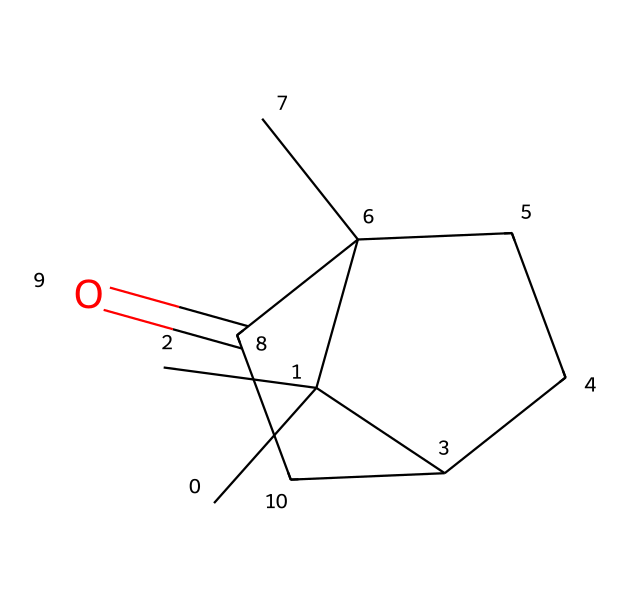What is the main functional group in camphor? The chemical structure of camphor contains a ketone group, identifiable by the carbonyl (C=O) bonded to two other carbon atoms. This functional group indicates that camphor is a ketone.
Answer: ketone How many carbon atoms are in the molecular structure of camphor? By analyzing the structure, we can count the number of carbon atoms in the skeleton. The chemical representation shows a total of 10 carbon atoms linked together.
Answer: 10 What type of molecule is camphor categorized as? Based on its structure and functional groups, camphor is identified as a bicyclic monoterpene, since it consists of two fused rings and has a total of 10 carbon atoms typical for monoterpenes.
Answer: bicyclic monoterpene What is the molecular formula of camphor? By calculating based on the number of carbon, hydrogen, and oxygen atoms in the structure, the molecular formula is deduced to be C10H16O.
Answer: C10H16O Does camphor have aromatic characteristics? The structure does not feature any delocalized pi electrons or planar ring systems characteristics of aromatic compounds, as it consists of closed, saturated rings without resonance.
Answer: no What is the use of camphor in outdoor gear? Camphor is commonly used for its preserving and antifungal properties, which help protect outdoor gear and adventure equipment against dampness and microbial growth.
Answer: preserving agent 